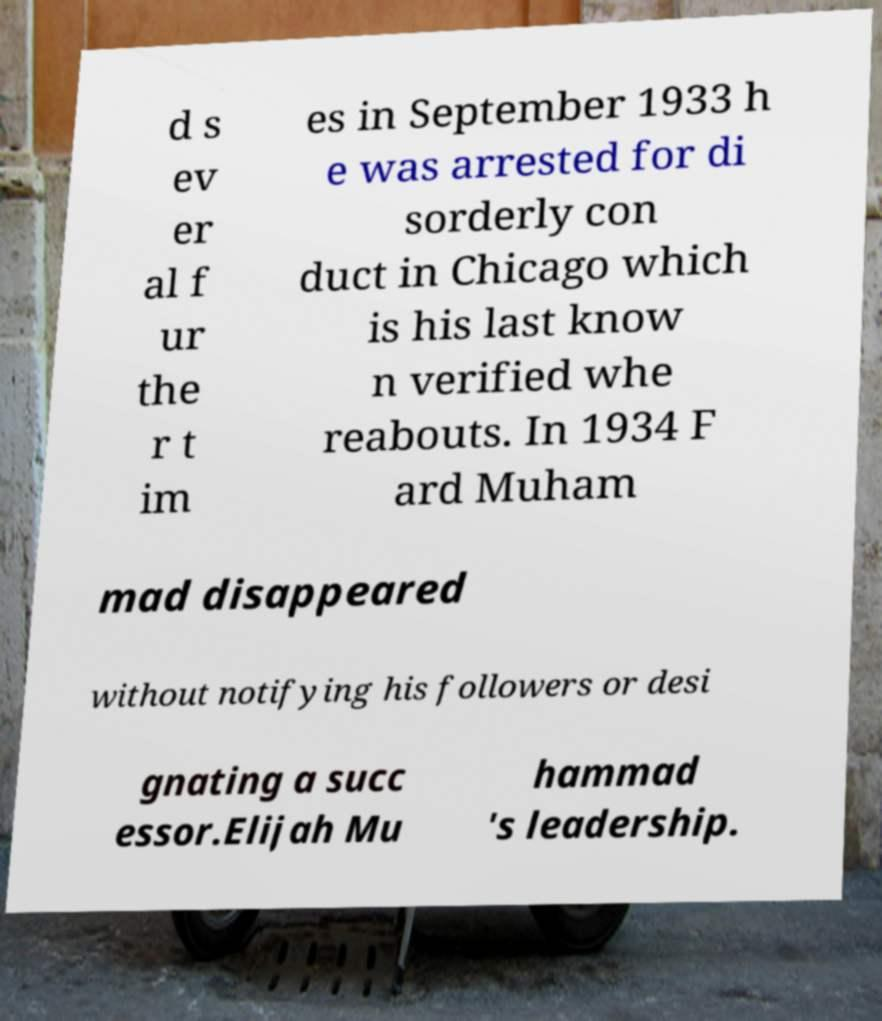Please read and relay the text visible in this image. What does it say? d s ev er al f ur the r t im es in September 1933 h e was arrested for di sorderly con duct in Chicago which is his last know n verified whe reabouts. In 1934 F ard Muham mad disappeared without notifying his followers or desi gnating a succ essor.Elijah Mu hammad 's leadership. 